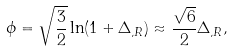<formula> <loc_0><loc_0><loc_500><loc_500>\phi = \sqrt { \frac { 3 } { 2 } } \ln ( 1 + \Delta _ { , R } ) \approx \frac { \sqrt { 6 } } { 2 } \Delta _ { , R } ,</formula> 